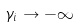Convert formula to latex. <formula><loc_0><loc_0><loc_500><loc_500>\gamma _ { i } \to - \infty</formula> 